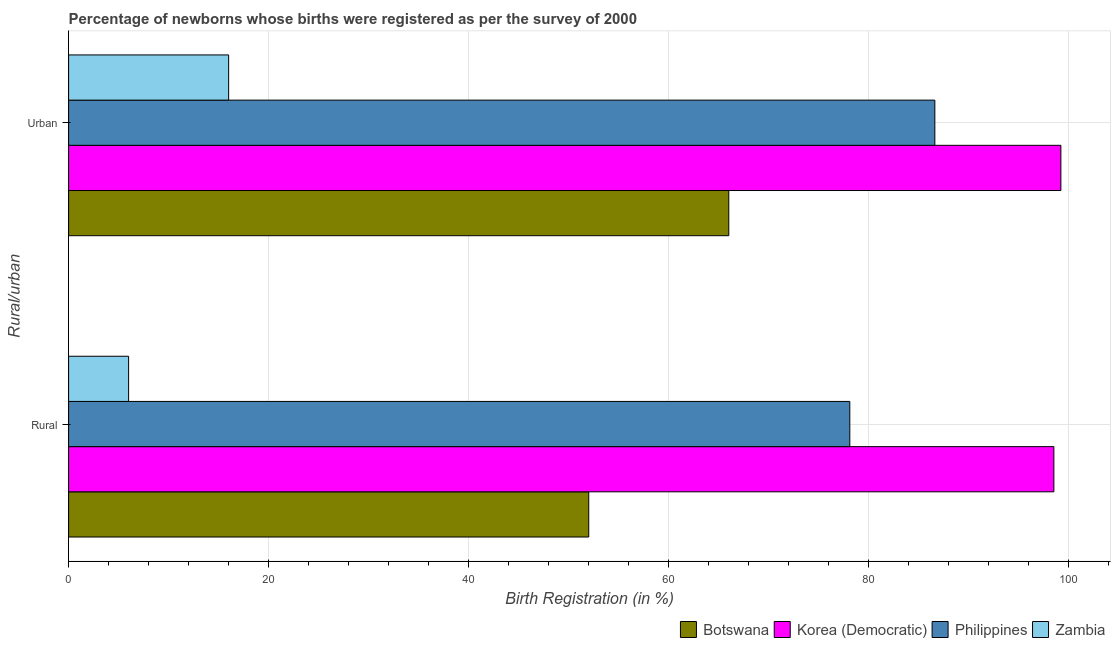How many different coloured bars are there?
Provide a succinct answer. 4. How many groups of bars are there?
Give a very brief answer. 2. Are the number of bars on each tick of the Y-axis equal?
Make the answer very short. Yes. What is the label of the 1st group of bars from the top?
Ensure brevity in your answer.  Urban. Across all countries, what is the maximum urban birth registration?
Provide a short and direct response. 99.2. Across all countries, what is the minimum rural birth registration?
Your answer should be very brief. 6. In which country was the rural birth registration maximum?
Provide a succinct answer. Korea (Democratic). In which country was the rural birth registration minimum?
Give a very brief answer. Zambia. What is the total urban birth registration in the graph?
Your answer should be very brief. 267.8. What is the difference between the rural birth registration in Philippines and that in Korea (Democratic)?
Your response must be concise. -20.4. What is the difference between the rural birth registration in Philippines and the urban birth registration in Zambia?
Give a very brief answer. 62.1. What is the average rural birth registration per country?
Give a very brief answer. 58.65. What is the difference between the urban birth registration and rural birth registration in Botswana?
Provide a succinct answer. 14. What is the ratio of the rural birth registration in Philippines to that in Zambia?
Ensure brevity in your answer.  13.02. In how many countries, is the urban birth registration greater than the average urban birth registration taken over all countries?
Offer a terse response. 2. What does the 3rd bar from the top in Rural represents?
Your response must be concise. Korea (Democratic). What does the 1st bar from the bottom in Rural represents?
Your response must be concise. Botswana. How many bars are there?
Provide a succinct answer. 8. Are all the bars in the graph horizontal?
Keep it short and to the point. Yes. Are the values on the major ticks of X-axis written in scientific E-notation?
Give a very brief answer. No. Does the graph contain grids?
Your answer should be compact. Yes. Where does the legend appear in the graph?
Your response must be concise. Bottom right. How are the legend labels stacked?
Your response must be concise. Horizontal. What is the title of the graph?
Your response must be concise. Percentage of newborns whose births were registered as per the survey of 2000. What is the label or title of the X-axis?
Your answer should be compact. Birth Registration (in %). What is the label or title of the Y-axis?
Your answer should be very brief. Rural/urban. What is the Birth Registration (in %) in Korea (Democratic) in Rural?
Provide a short and direct response. 98.5. What is the Birth Registration (in %) of Philippines in Rural?
Your answer should be very brief. 78.1. What is the Birth Registration (in %) of Botswana in Urban?
Ensure brevity in your answer.  66. What is the Birth Registration (in %) of Korea (Democratic) in Urban?
Provide a short and direct response. 99.2. What is the Birth Registration (in %) of Philippines in Urban?
Give a very brief answer. 86.6. What is the Birth Registration (in %) of Zambia in Urban?
Provide a succinct answer. 16. Across all Rural/urban, what is the maximum Birth Registration (in %) in Botswana?
Make the answer very short. 66. Across all Rural/urban, what is the maximum Birth Registration (in %) of Korea (Democratic)?
Your answer should be very brief. 99.2. Across all Rural/urban, what is the maximum Birth Registration (in %) of Philippines?
Provide a short and direct response. 86.6. Across all Rural/urban, what is the maximum Birth Registration (in %) of Zambia?
Provide a short and direct response. 16. Across all Rural/urban, what is the minimum Birth Registration (in %) in Korea (Democratic)?
Your answer should be compact. 98.5. Across all Rural/urban, what is the minimum Birth Registration (in %) in Philippines?
Give a very brief answer. 78.1. Across all Rural/urban, what is the minimum Birth Registration (in %) in Zambia?
Provide a succinct answer. 6. What is the total Birth Registration (in %) in Botswana in the graph?
Give a very brief answer. 118. What is the total Birth Registration (in %) in Korea (Democratic) in the graph?
Provide a succinct answer. 197.7. What is the total Birth Registration (in %) in Philippines in the graph?
Keep it short and to the point. 164.7. What is the total Birth Registration (in %) of Zambia in the graph?
Provide a succinct answer. 22. What is the difference between the Birth Registration (in %) of Botswana in Rural and that in Urban?
Your response must be concise. -14. What is the difference between the Birth Registration (in %) of Korea (Democratic) in Rural and that in Urban?
Offer a very short reply. -0.7. What is the difference between the Birth Registration (in %) of Botswana in Rural and the Birth Registration (in %) of Korea (Democratic) in Urban?
Offer a terse response. -47.2. What is the difference between the Birth Registration (in %) of Botswana in Rural and the Birth Registration (in %) of Philippines in Urban?
Provide a short and direct response. -34.6. What is the difference between the Birth Registration (in %) in Botswana in Rural and the Birth Registration (in %) in Zambia in Urban?
Offer a very short reply. 36. What is the difference between the Birth Registration (in %) of Korea (Democratic) in Rural and the Birth Registration (in %) of Zambia in Urban?
Make the answer very short. 82.5. What is the difference between the Birth Registration (in %) of Philippines in Rural and the Birth Registration (in %) of Zambia in Urban?
Offer a very short reply. 62.1. What is the average Birth Registration (in %) of Korea (Democratic) per Rural/urban?
Give a very brief answer. 98.85. What is the average Birth Registration (in %) in Philippines per Rural/urban?
Ensure brevity in your answer.  82.35. What is the difference between the Birth Registration (in %) of Botswana and Birth Registration (in %) of Korea (Democratic) in Rural?
Provide a short and direct response. -46.5. What is the difference between the Birth Registration (in %) of Botswana and Birth Registration (in %) of Philippines in Rural?
Ensure brevity in your answer.  -26.1. What is the difference between the Birth Registration (in %) of Botswana and Birth Registration (in %) of Zambia in Rural?
Make the answer very short. 46. What is the difference between the Birth Registration (in %) of Korea (Democratic) and Birth Registration (in %) of Philippines in Rural?
Keep it short and to the point. 20.4. What is the difference between the Birth Registration (in %) in Korea (Democratic) and Birth Registration (in %) in Zambia in Rural?
Offer a very short reply. 92.5. What is the difference between the Birth Registration (in %) in Philippines and Birth Registration (in %) in Zambia in Rural?
Your answer should be very brief. 72.1. What is the difference between the Birth Registration (in %) in Botswana and Birth Registration (in %) in Korea (Democratic) in Urban?
Offer a very short reply. -33.2. What is the difference between the Birth Registration (in %) of Botswana and Birth Registration (in %) of Philippines in Urban?
Offer a terse response. -20.6. What is the difference between the Birth Registration (in %) in Korea (Democratic) and Birth Registration (in %) in Philippines in Urban?
Offer a very short reply. 12.6. What is the difference between the Birth Registration (in %) in Korea (Democratic) and Birth Registration (in %) in Zambia in Urban?
Your response must be concise. 83.2. What is the difference between the Birth Registration (in %) in Philippines and Birth Registration (in %) in Zambia in Urban?
Give a very brief answer. 70.6. What is the ratio of the Birth Registration (in %) in Botswana in Rural to that in Urban?
Provide a short and direct response. 0.79. What is the ratio of the Birth Registration (in %) in Korea (Democratic) in Rural to that in Urban?
Your answer should be very brief. 0.99. What is the ratio of the Birth Registration (in %) of Philippines in Rural to that in Urban?
Offer a terse response. 0.9. What is the ratio of the Birth Registration (in %) in Zambia in Rural to that in Urban?
Provide a short and direct response. 0.38. What is the difference between the highest and the second highest Birth Registration (in %) of Korea (Democratic)?
Offer a terse response. 0.7. What is the difference between the highest and the lowest Birth Registration (in %) of Zambia?
Give a very brief answer. 10. 